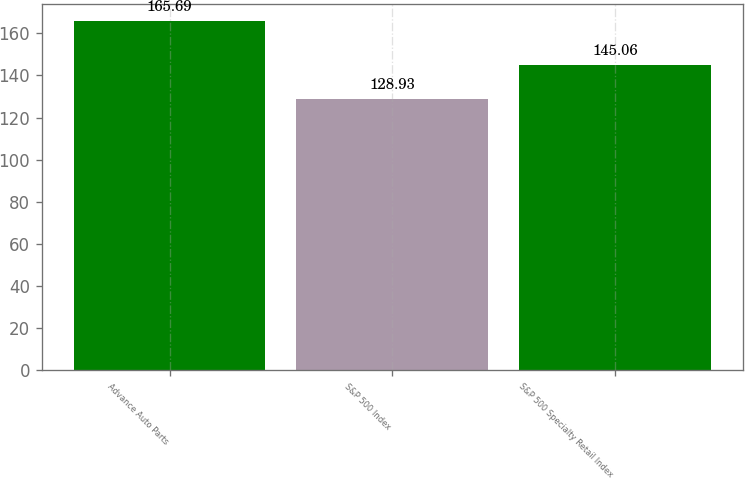<chart> <loc_0><loc_0><loc_500><loc_500><bar_chart><fcel>Advance Auto Parts<fcel>S&P 500 Index<fcel>S&P 500 Specialty Retail Index<nl><fcel>165.69<fcel>128.93<fcel>145.06<nl></chart> 